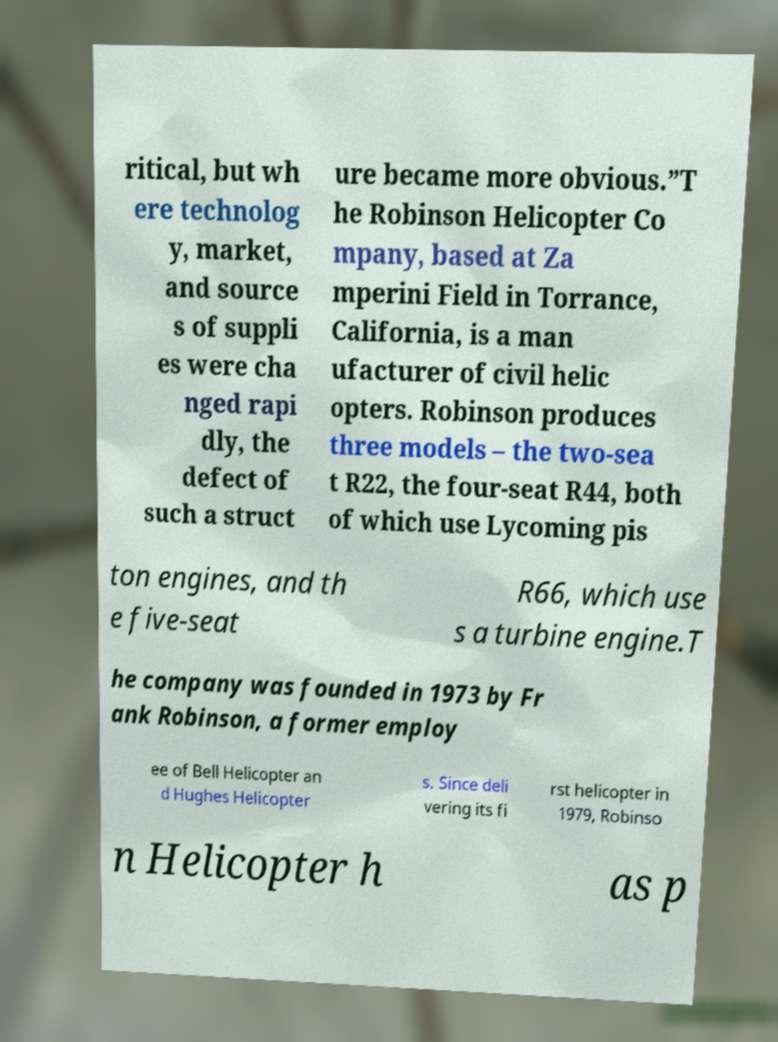Can you read and provide the text displayed in the image?This photo seems to have some interesting text. Can you extract and type it out for me? ritical, but wh ere technolog y, market, and source s of suppli es were cha nged rapi dly, the defect of such a struct ure became more obvious.”T he Robinson Helicopter Co mpany, based at Za mperini Field in Torrance, California, is a man ufacturer of civil helic opters. Robinson produces three models – the two-sea t R22, the four-seat R44, both of which use Lycoming pis ton engines, and th e five-seat R66, which use s a turbine engine.T he company was founded in 1973 by Fr ank Robinson, a former employ ee of Bell Helicopter an d Hughes Helicopter s. Since deli vering its fi rst helicopter in 1979, Robinso n Helicopter h as p 